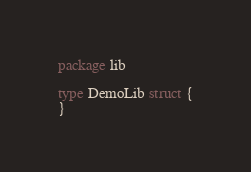<code> <loc_0><loc_0><loc_500><loc_500><_Go_>package lib

type DemoLib struct {
}
</code> 